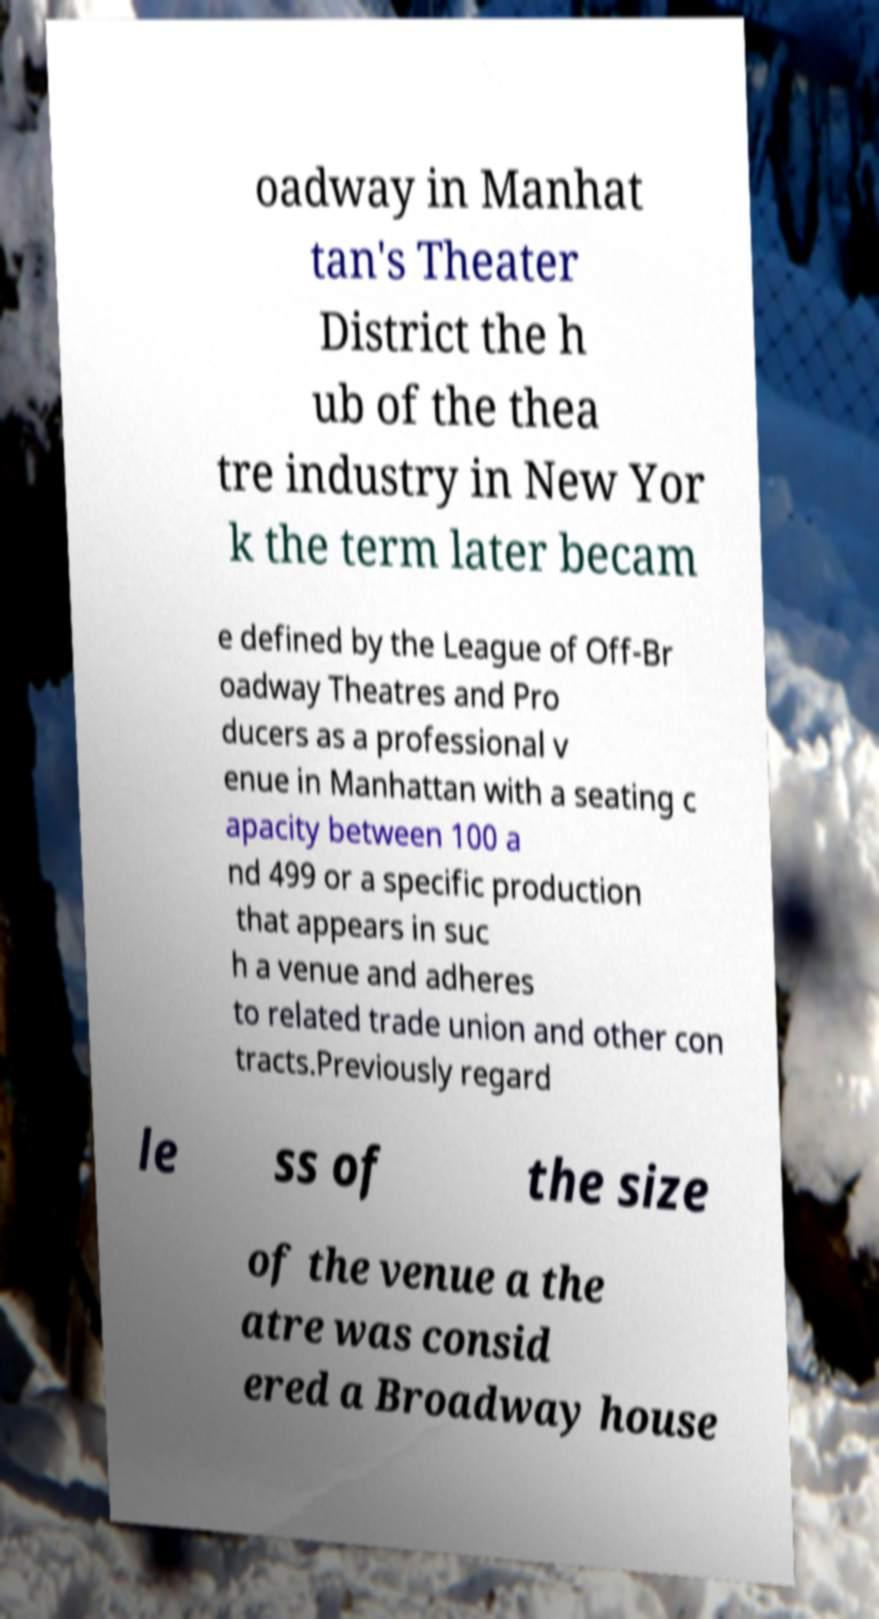Could you assist in decoding the text presented in this image and type it out clearly? oadway in Manhat tan's Theater District the h ub of the thea tre industry in New Yor k the term later becam e defined by the League of Off-Br oadway Theatres and Pro ducers as a professional v enue in Manhattan with a seating c apacity between 100 a nd 499 or a specific production that appears in suc h a venue and adheres to related trade union and other con tracts.Previously regard le ss of the size of the venue a the atre was consid ered a Broadway house 